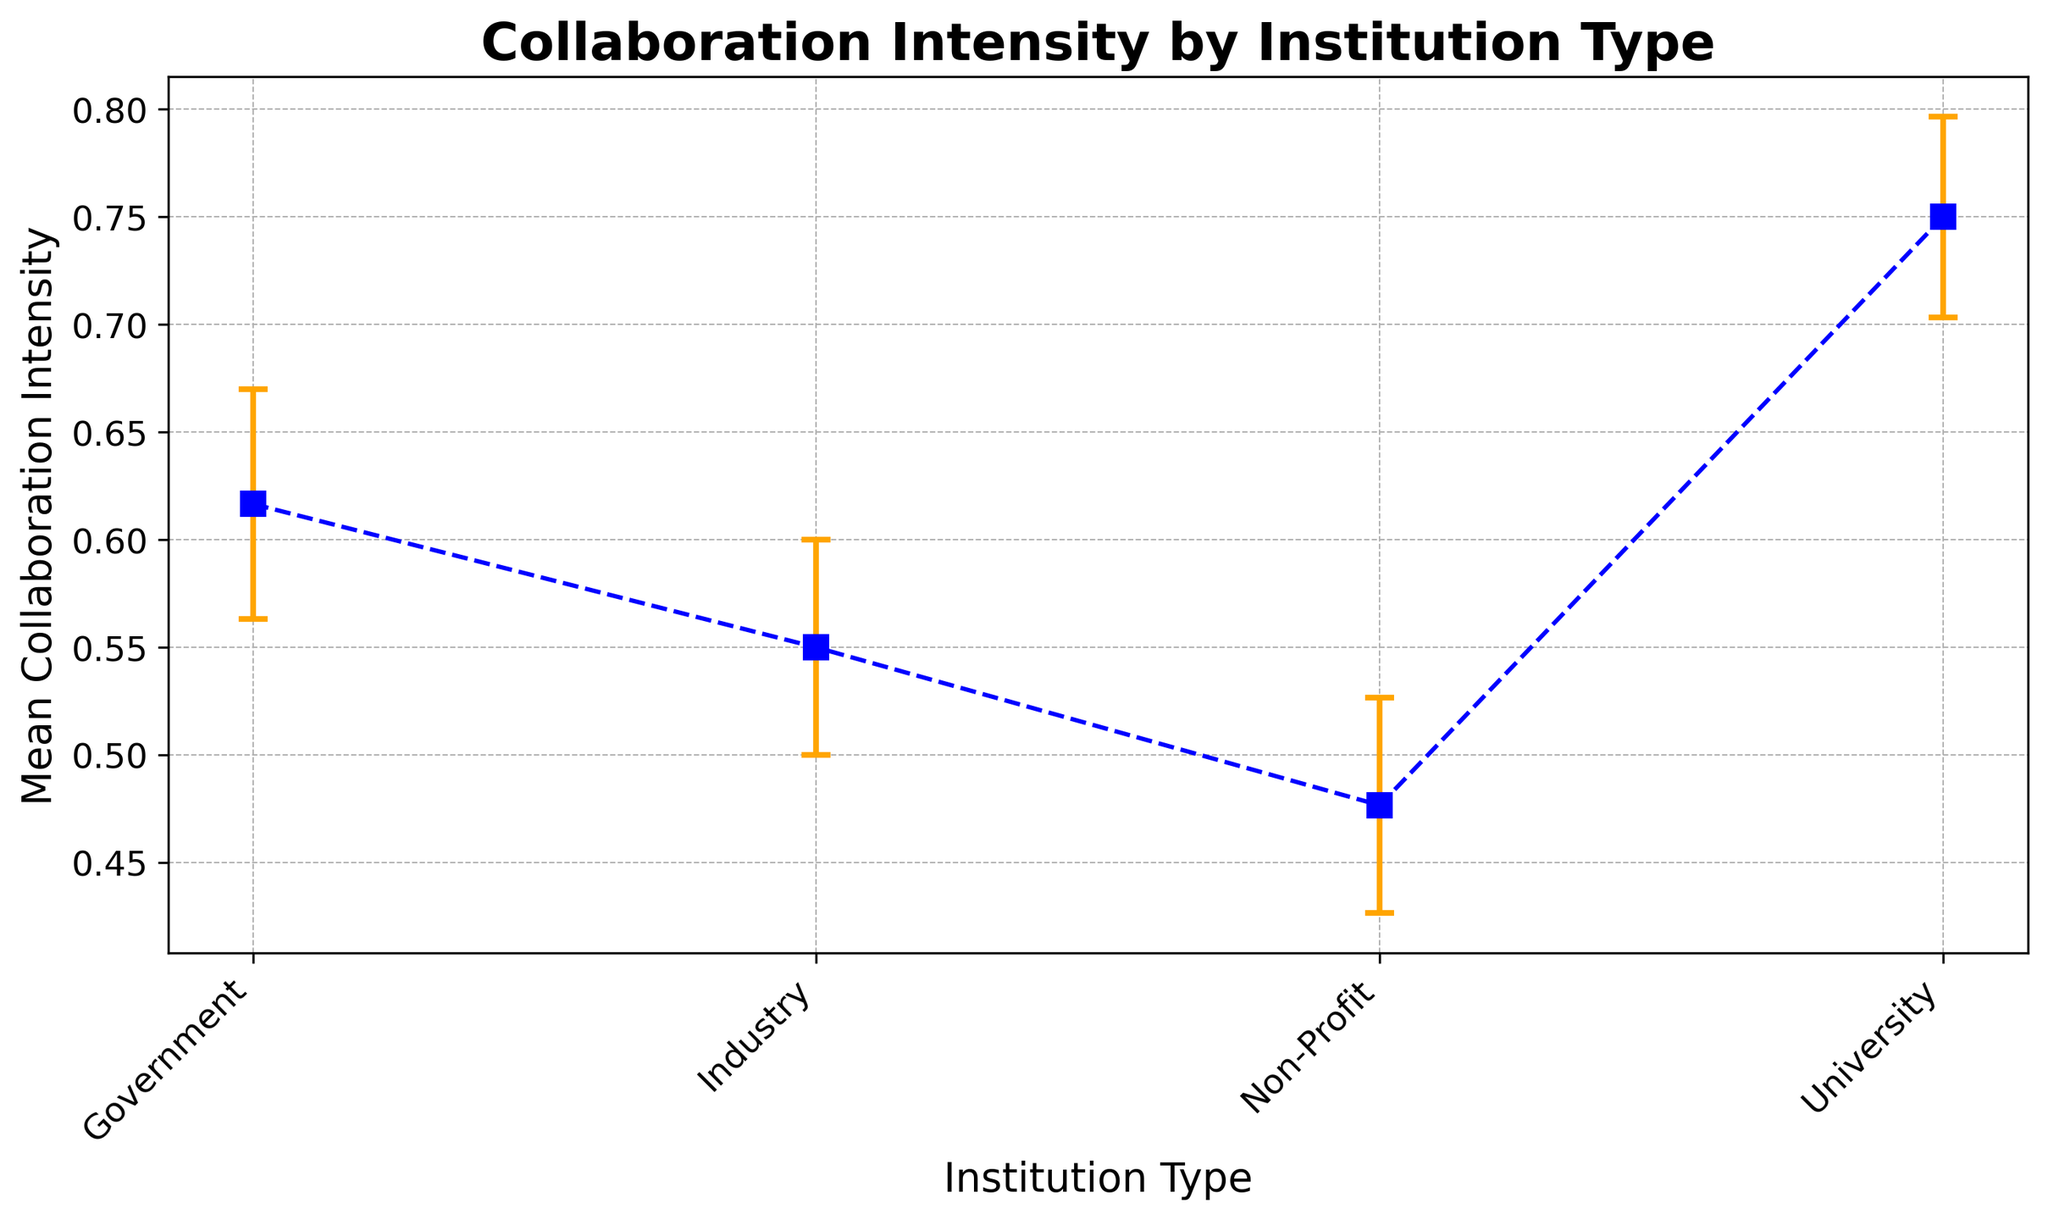What is the institution type with the highest mean collaboration intensity? Looking at the plot, the highest error bar's midpoint for mean collaboration intensity is for 'University'.
Answer: University What is the difference in mean collaboration intensity between universities and non-profit organizations? The mean collaboration intensity for universities is approximately 0.75, and for non-profits, it is approximately 0.48. The difference is 0.75 - 0.48.
Answer: 0.27 Which institution type has the highest variability in collaboration outcomes? The institution type with the widest error bars, indicating the highest variability, is 'University'.
Answer: University What is the range of collaboration intensity for government institutions? From the plot, the mean collaboration intensity for government institutions is around 0.62, with lower and upper error values suggesting a range from approximately 0.57 to 0.67.
Answer: 0.57 to 0.67 Compare the mean collaboration intensity for industry and non-profit institutions. Which one is higher? The plot shows that the mean collaboration intensity for industry is approximately 0.55, while it is approximately 0.48 for non-profits. Thus, industry is higher.
Answer: Industry What is the average mean collaboration intensity among all institution types? The mean collaboration intensities for the institution types are 0.75 (University), 0.55 (Industry), 0.62 (Government), and 0.48 (Non-Profit). The average is (0.75 + 0.55 + 0.62 + 0.48) / 4.
Answer: 0.6 Which two institution types have the closest mean collaboration intensity? The plot shows that government (0.62) and industry (0.55) have mean collaboration intensities that are the closest to each other.
Answer: Government and Industry How do the lower error bounds for universities and non-profits compare? For universities, the lower error bound is about 0.70, while for non-profits, it is approximately 0.43.
Answer: Universities are higher Which institution type has the smallest upper error value and what is it? Non-profit organizations have the smallest upper error value, approximately 0.53, based on the shortest upper error bar.
Answer: Non-Profit, 0.53 